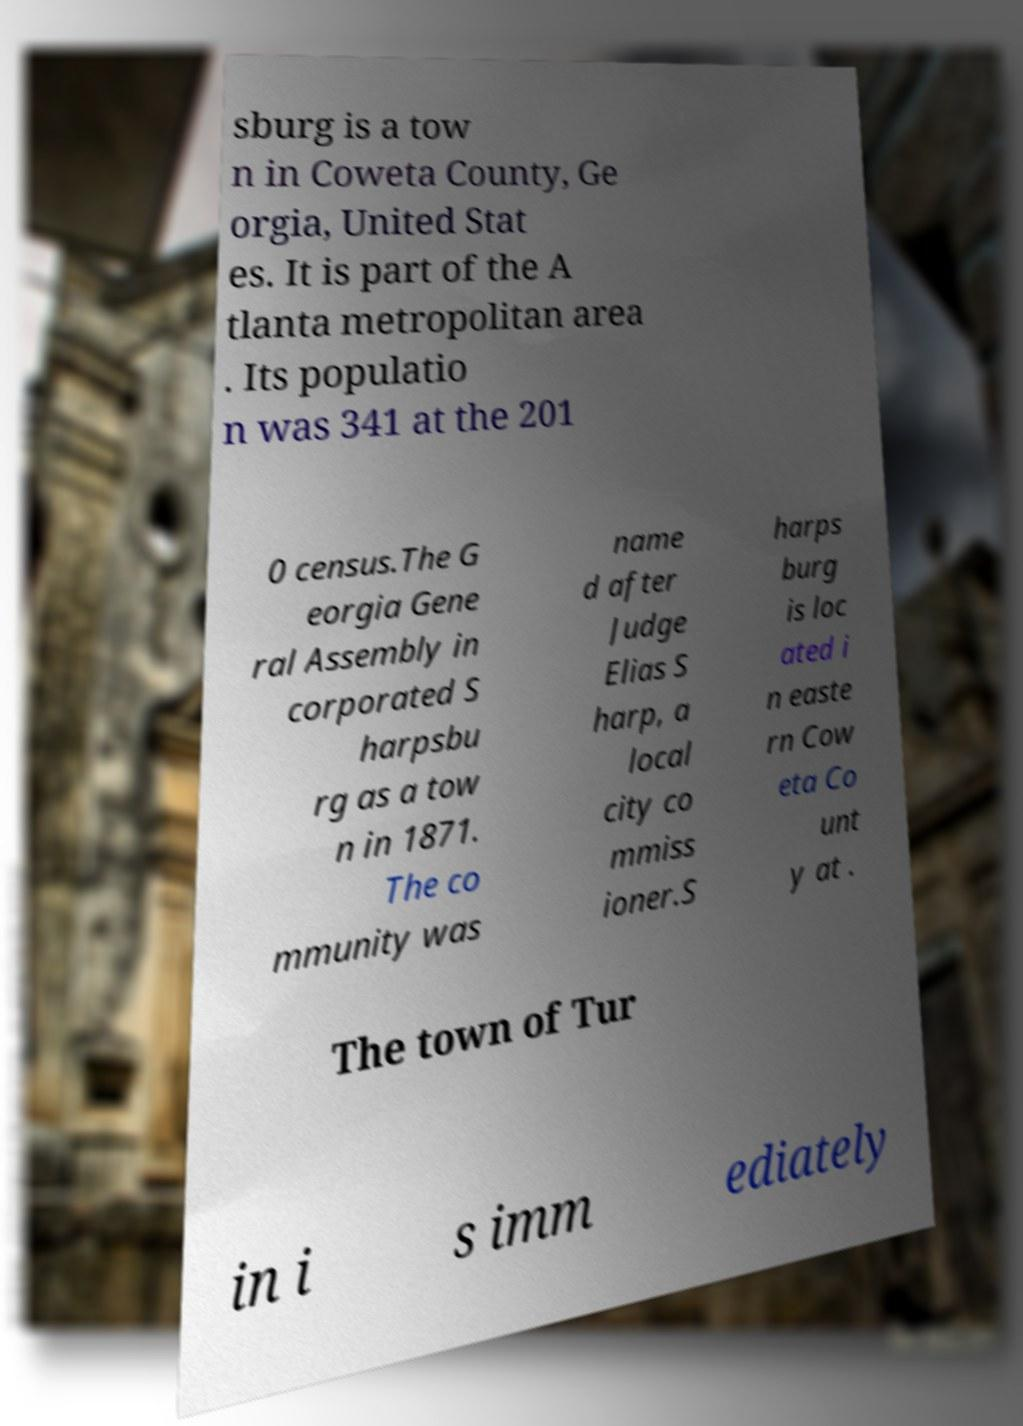What messages or text are displayed in this image? I need them in a readable, typed format. sburg is a tow n in Coweta County, Ge orgia, United Stat es. It is part of the A tlanta metropolitan area . Its populatio n was 341 at the 201 0 census.The G eorgia Gene ral Assembly in corporated S harpsbu rg as a tow n in 1871. The co mmunity was name d after Judge Elias S harp, a local city co mmiss ioner.S harps burg is loc ated i n easte rn Cow eta Co unt y at . The town of Tur in i s imm ediately 